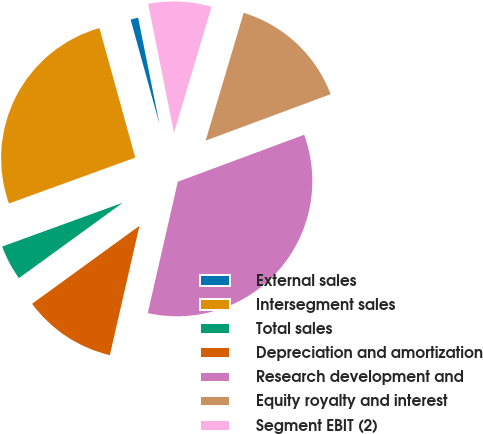<chart> <loc_0><loc_0><loc_500><loc_500><pie_chart><fcel>External sales<fcel>Intersegment sales<fcel>Total sales<fcel>Depreciation and amortization<fcel>Research development and<fcel>Equity royalty and interest<fcel>Segment EBIT (2)<nl><fcel>1.14%<fcel>26.26%<fcel>4.45%<fcel>11.42%<fcel>34.25%<fcel>14.73%<fcel>7.76%<nl></chart> 